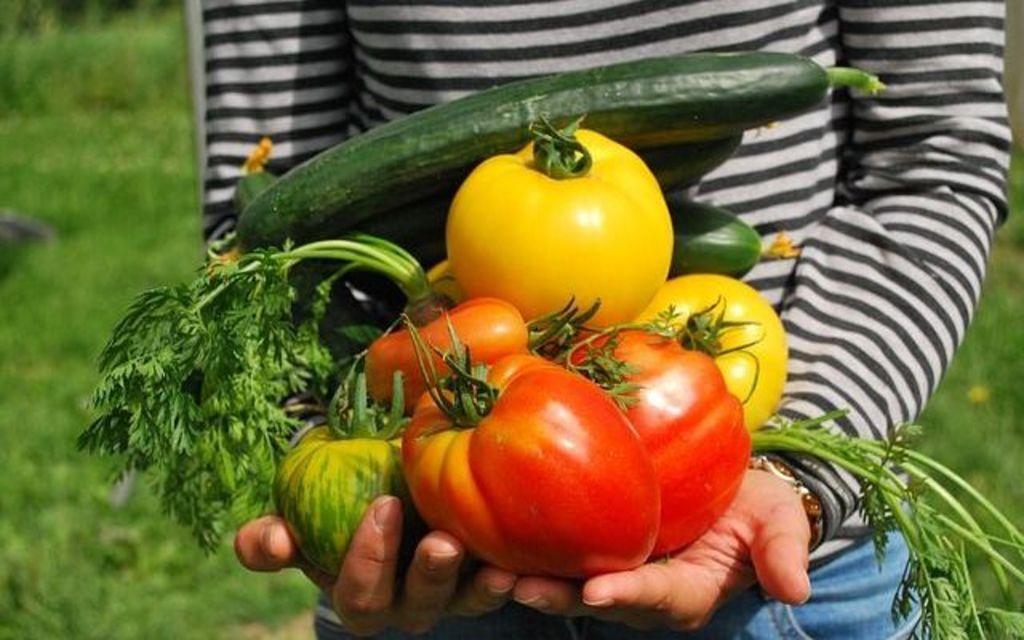How would you summarize this image in a sentence or two? In the picture we can see some person standing on the grass surface and holding some vegetables in the hands, he is wearing a full T-shirt with a blue color trouser. 